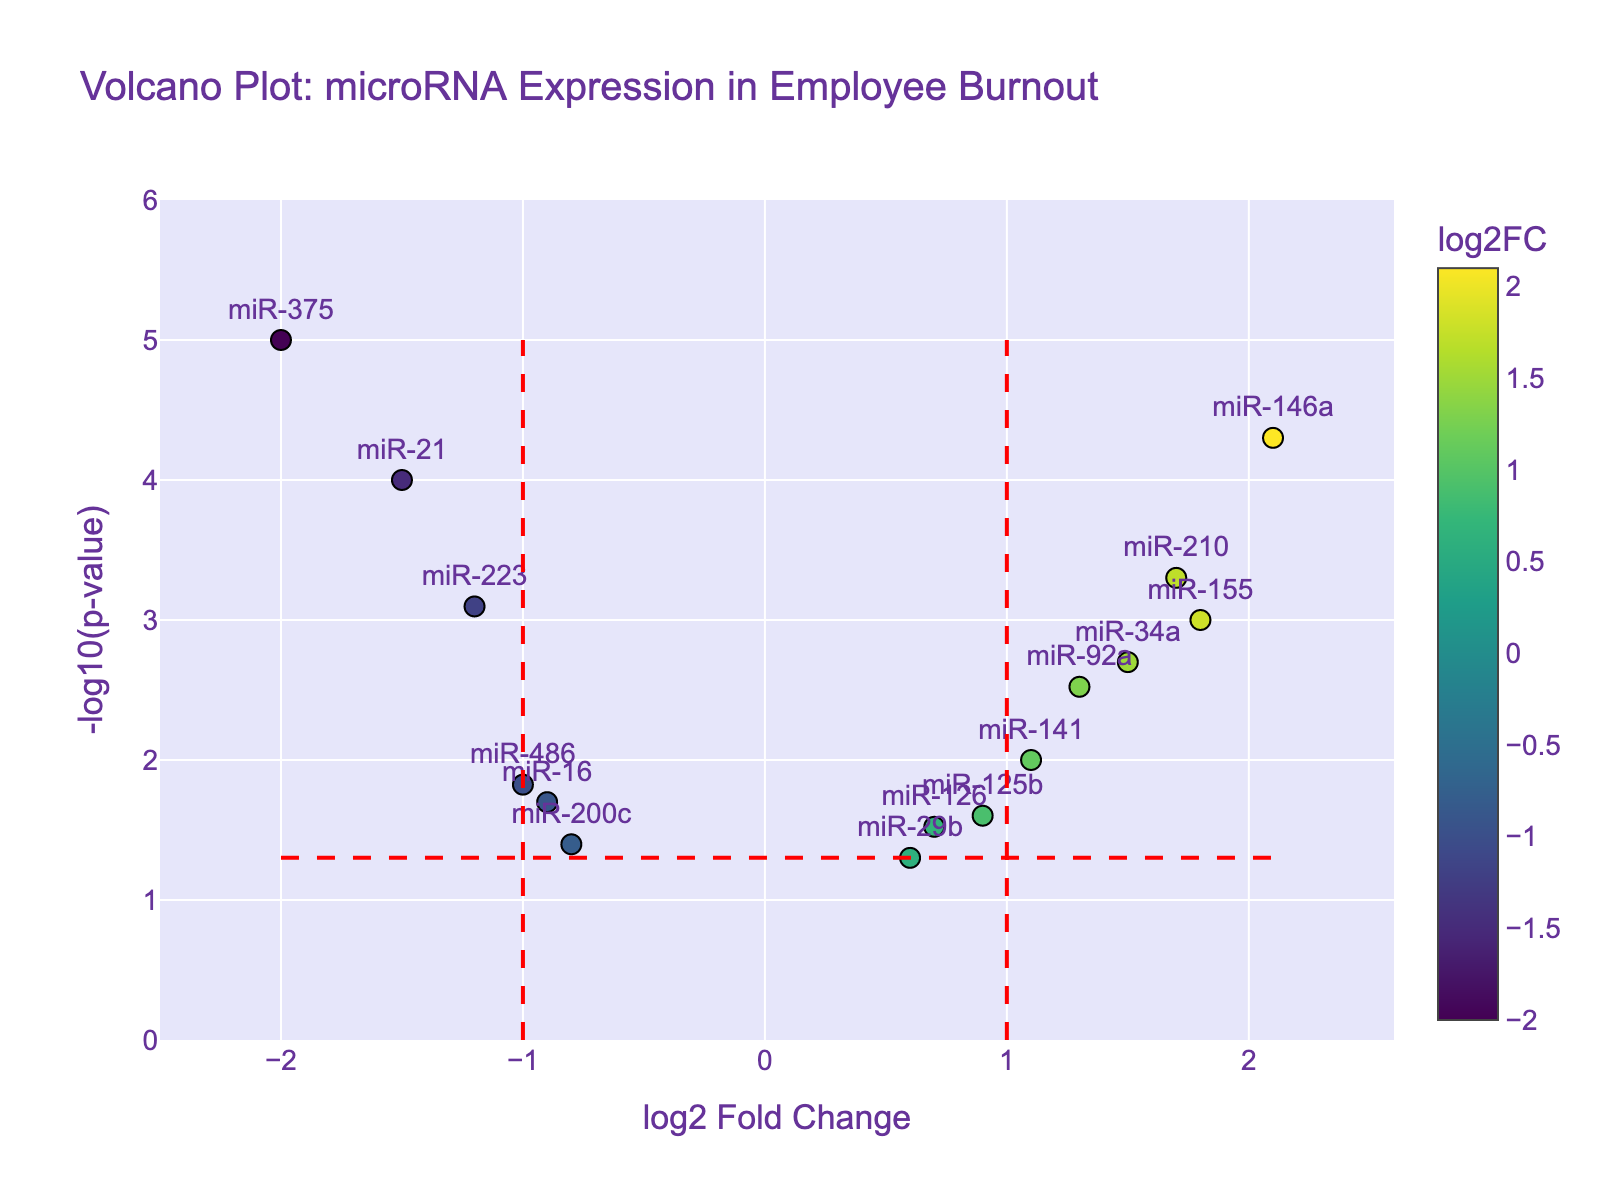What is the title of the plot? The title of the plot is displayed at the top of the figure. Reading it directly will give us the title.
Answer: Volcano Plot: microRNA Expression in Employee Burnout How many microRNAs have a p-value less than 0.01? To determine this, look for points with a y-axis value above -log10(0.01).
Answer: 9 Which microRNA shows the largest positive log2 fold change in expression? To find this, identify the point farthest to the right on the x-axis.
Answer: miR-146a Which microRNA has the smallest p-value? The smallest p-value corresponds to the highest y-axis point. From the hovertext, find the microRNA with the highest -log10(p-value).
Answer: miR-375 How many microRNAs have a log2 fold change greater than 1? Points with log2 fold changes greater than 1 are to the right of the vertical line at log2FC = 1. Count these points.
Answer: 6 Which microRNA shows a log2 fold change close to -1 and has a significant p-value (< 0.05)? Look for points near x = -1 with y-axis values above the horizontal line representing significance (-log10(0.05)).
Answer: miR-21 What is the approximate -log10(p-value) for miR-155? Find the point labeled miR-155 and read its y-axis value.
Answer: 3 Which microRNAs show significant downregulation (log2FC < -1, p-value < 0.05)? Look for points to the left of the vertical line at log2FC = -1, above the horizontal line at -log10(0.05).
Answer: miR-21, miR-375, miR-223 Are there more upregulated (log2FC > 0) or downregulated (log2FC < 0) microRNAs? Compare the number of points to the left of zero to the number to the right.
Answer: More upregulated What is the relationship between miR-210's log2 fold change and its significance? For miR-210, determine the relationship by comparing its hovertext log2FC value (~1.7) and significance (y-axis value).
Answer: Highly significant upregulation 